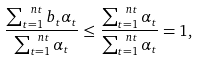<formula> <loc_0><loc_0><loc_500><loc_500>\frac { \sum _ { t = 1 } ^ { \ n t } b _ { t } \alpha _ { t } } { \sum _ { t = 1 } ^ { \ n t } \alpha _ { t } } \leq \frac { \sum _ { t = 1 } ^ { \ n t } \alpha _ { t } } { \sum _ { t = 1 } ^ { \ n t } \alpha _ { t } } = 1 ,</formula> 